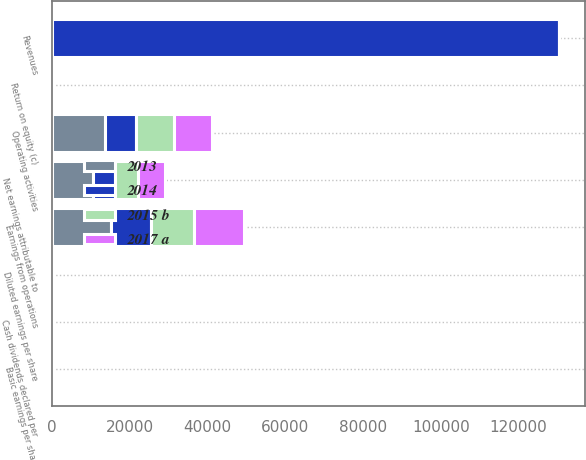Convert chart. <chart><loc_0><loc_0><loc_500><loc_500><stacked_bar_chart><ecel><fcel>Revenues<fcel>Earnings from operations<fcel>Net earnings attributable to<fcel>Return on equity (c)<fcel>Basic earnings per share<fcel>Diluted earnings per share<fcel>Cash dividends declared per<fcel>Operating activities<nl><fcel>2013<fcel>19.4<fcel>15209<fcel>10558<fcel>24.4<fcel>10.95<fcel>10.72<fcel>2.88<fcel>13596<nl><fcel>2017 a<fcel>19.4<fcel>12930<fcel>7017<fcel>19.4<fcel>7.37<fcel>7.25<fcel>2.38<fcel>9795<nl><fcel>2015 b<fcel>19.4<fcel>11021<fcel>5813<fcel>17.7<fcel>6.1<fcel>6.01<fcel>1.88<fcel>9740<nl><fcel>2014<fcel>130474<fcel>10274<fcel>5619<fcel>17.3<fcel>5.78<fcel>5.7<fcel>1.41<fcel>8051<nl></chart> 